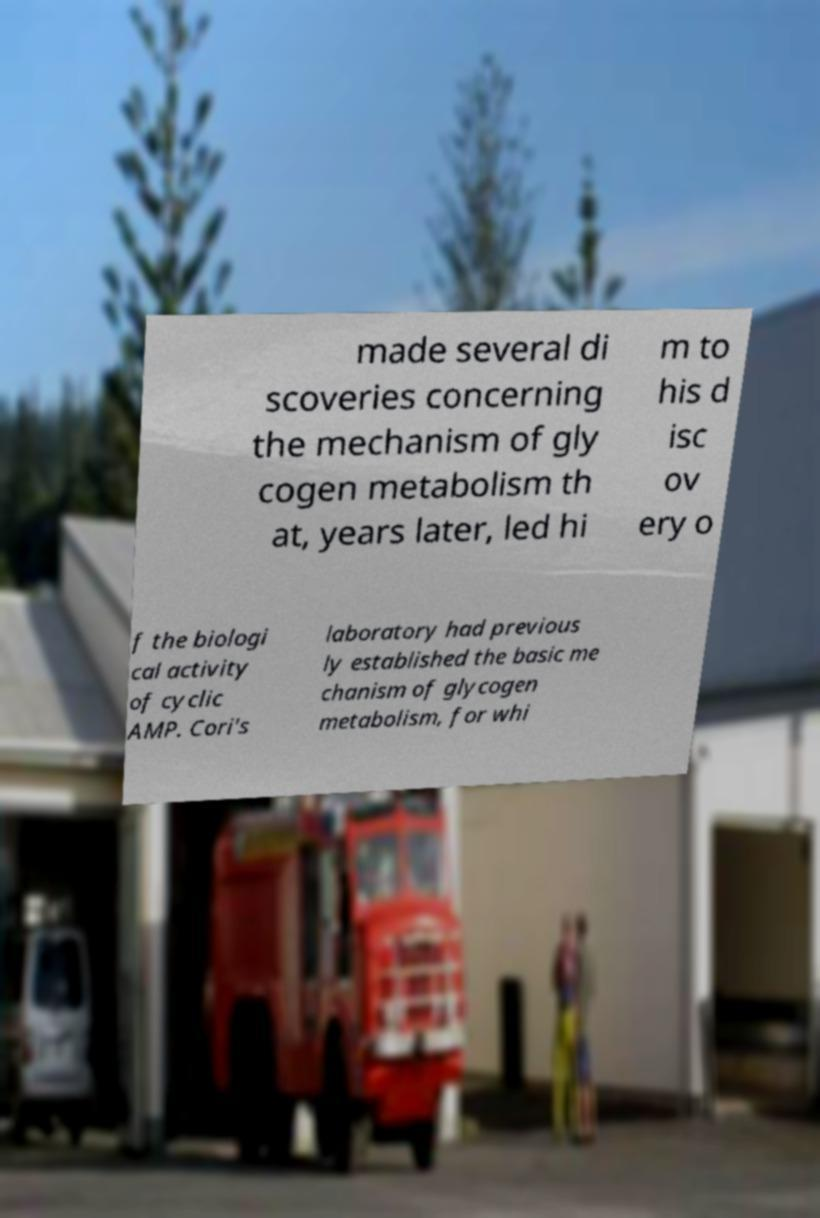What messages or text are displayed in this image? I need them in a readable, typed format. made several di scoveries concerning the mechanism of gly cogen metabolism th at, years later, led hi m to his d isc ov ery o f the biologi cal activity of cyclic AMP. Cori's laboratory had previous ly established the basic me chanism of glycogen metabolism, for whi 